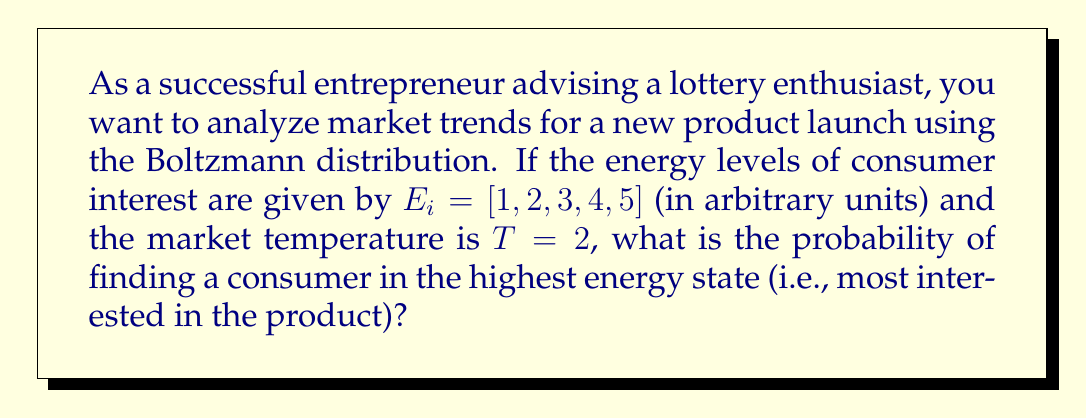Provide a solution to this math problem. To solve this problem, we'll use the Boltzmann distribution, which is analogous to market behavior:

1) The Boltzmann distribution is given by:
   $$P_i = \frac{e^{-E_i/kT}}{\sum_j e^{-E_j/kT}}$$
   where $P_i$ is the probability of state $i$, $E_i$ is the energy of state $i$, $k$ is Boltzmann's constant (which we'll treat as 1 for simplicity), and $T$ is the temperature.

2) Calculate the denominator (partition function):
   $$Z = \sum_j e^{-E_j/kT} = e^{-1/2} + e^{-2/2} + e^{-3/2} + e^{-4/2} + e^{-5/2}$$

3) Calculate the numerator for the highest energy state ($E_5 = 5$):
   $$e^{-E_5/kT} = e^{-5/2}$$

4) Divide the numerator by the denominator:
   $$P_5 = \frac{e^{-5/2}}{e^{-1/2} + e^{-2/2} + e^{-3/2} + e^{-4/2} + e^{-5/2}}$$

5) Evaluate this expression numerically:
   $$P_5 \approx 0.0432 \text{ or } 4.32\%$$

This probability represents the likelihood of finding a consumer in the highest interest state for the new product launch.
Answer: 0.0432 or 4.32% 